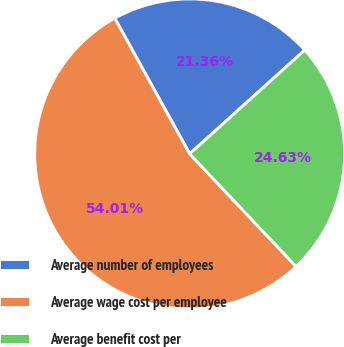<chart> <loc_0><loc_0><loc_500><loc_500><pie_chart><fcel>Average number of employees<fcel>Average wage cost per employee<fcel>Average benefit cost per<nl><fcel>21.36%<fcel>54.01%<fcel>24.63%<nl></chart> 